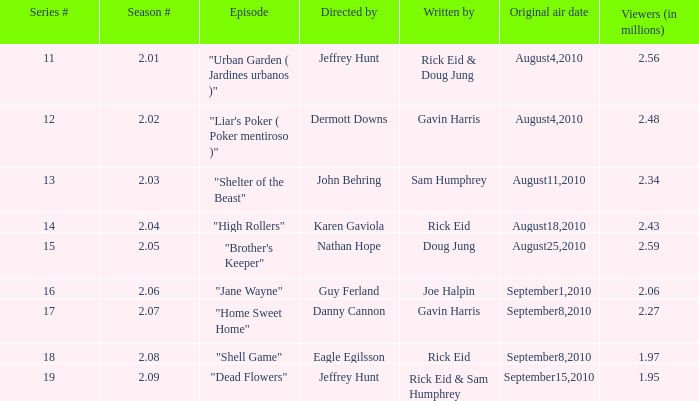08? 18.0. 